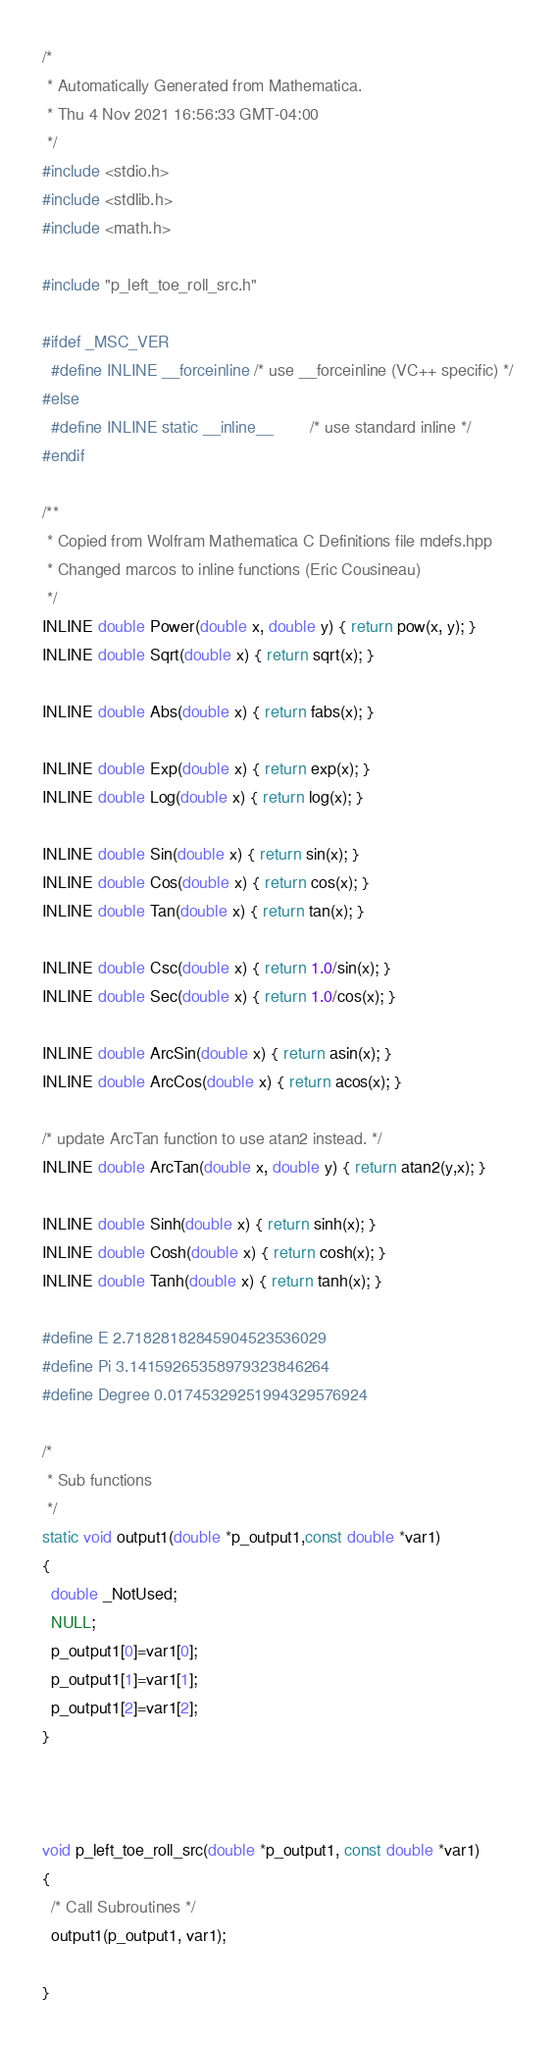Convert code to text. <code><loc_0><loc_0><loc_500><loc_500><_C_>/*
 * Automatically Generated from Mathematica.
 * Thu 4 Nov 2021 16:56:33 GMT-04:00
 */
#include <stdio.h>
#include <stdlib.h>
#include <math.h>

#include "p_left_toe_roll_src.h"

#ifdef _MSC_VER
  #define INLINE __forceinline /* use __forceinline (VC++ specific) */
#else
  #define INLINE static __inline__        /* use standard inline */
#endif

/**
 * Copied from Wolfram Mathematica C Definitions file mdefs.hpp
 * Changed marcos to inline functions (Eric Cousineau)
 */
INLINE double Power(double x, double y) { return pow(x, y); }
INLINE double Sqrt(double x) { return sqrt(x); }

INLINE double Abs(double x) { return fabs(x); }

INLINE double Exp(double x) { return exp(x); }
INLINE double Log(double x) { return log(x); }

INLINE double Sin(double x) { return sin(x); }
INLINE double Cos(double x) { return cos(x); }
INLINE double Tan(double x) { return tan(x); }

INLINE double Csc(double x) { return 1.0/sin(x); }
INLINE double Sec(double x) { return 1.0/cos(x); }

INLINE double ArcSin(double x) { return asin(x); }
INLINE double ArcCos(double x) { return acos(x); }

/* update ArcTan function to use atan2 instead. */
INLINE double ArcTan(double x, double y) { return atan2(y,x); }

INLINE double Sinh(double x) { return sinh(x); }
INLINE double Cosh(double x) { return cosh(x); }
INLINE double Tanh(double x) { return tanh(x); }

#define E 2.71828182845904523536029
#define Pi 3.14159265358979323846264
#define Degree 0.01745329251994329576924

/*
 * Sub functions
 */
static void output1(double *p_output1,const double *var1)
{
  double _NotUsed;
  NULL;
  p_output1[0]=var1[0];
  p_output1[1]=var1[1];
  p_output1[2]=var1[2];
}



void p_left_toe_roll_src(double *p_output1, const double *var1)
{
  /* Call Subroutines */
  output1(p_output1, var1);

}
</code> 